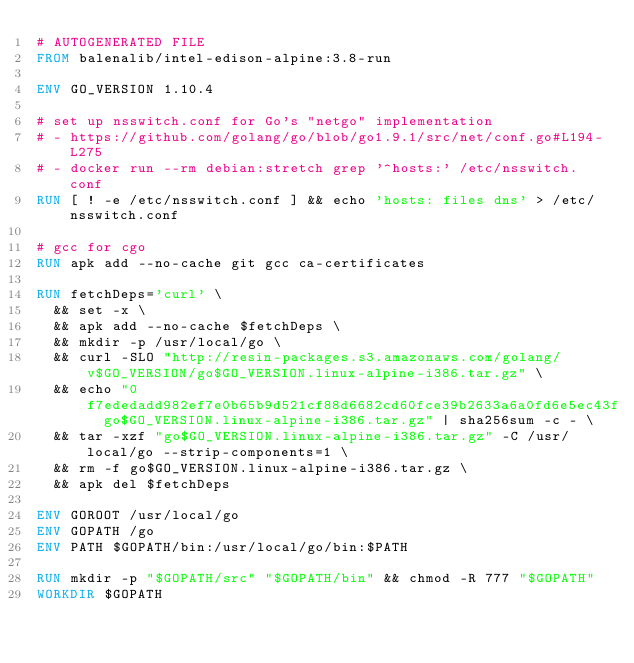<code> <loc_0><loc_0><loc_500><loc_500><_Dockerfile_># AUTOGENERATED FILE
FROM balenalib/intel-edison-alpine:3.8-run

ENV GO_VERSION 1.10.4

# set up nsswitch.conf for Go's "netgo" implementation
# - https://github.com/golang/go/blob/go1.9.1/src/net/conf.go#L194-L275
# - docker run --rm debian:stretch grep '^hosts:' /etc/nsswitch.conf
RUN [ ! -e /etc/nsswitch.conf ] && echo 'hosts: files dns' > /etc/nsswitch.conf

# gcc for cgo
RUN apk add --no-cache git gcc ca-certificates

RUN fetchDeps='curl' \
	&& set -x \
	&& apk add --no-cache $fetchDeps \
	&& mkdir -p /usr/local/go \
	&& curl -SLO "http://resin-packages.s3.amazonaws.com/golang/v$GO_VERSION/go$GO_VERSION.linux-alpine-i386.tar.gz" \
	&& echo "0f7ededadd982ef7e0b65b9d521cf88d6682cd60fce39b2633a6a0fd6e5ec43f  go$GO_VERSION.linux-alpine-i386.tar.gz" | sha256sum -c - \
	&& tar -xzf "go$GO_VERSION.linux-alpine-i386.tar.gz" -C /usr/local/go --strip-components=1 \
	&& rm -f go$GO_VERSION.linux-alpine-i386.tar.gz \
	&& apk del $fetchDeps

ENV GOROOT /usr/local/go
ENV GOPATH /go
ENV PATH $GOPATH/bin:/usr/local/go/bin:$PATH

RUN mkdir -p "$GOPATH/src" "$GOPATH/bin" && chmod -R 777 "$GOPATH"
WORKDIR $GOPATH
</code> 